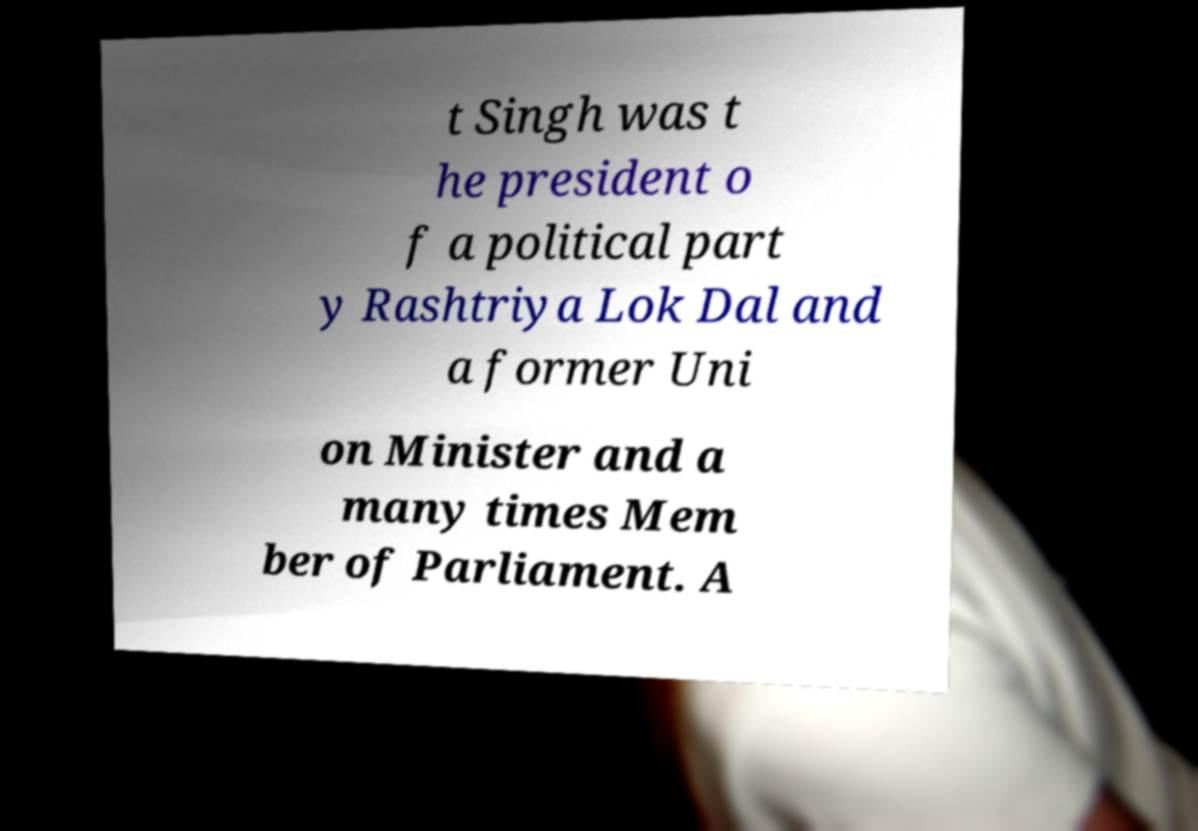What messages or text are displayed in this image? I need them in a readable, typed format. t Singh was t he president o f a political part y Rashtriya Lok Dal and a former Uni on Minister and a many times Mem ber of Parliament. A 